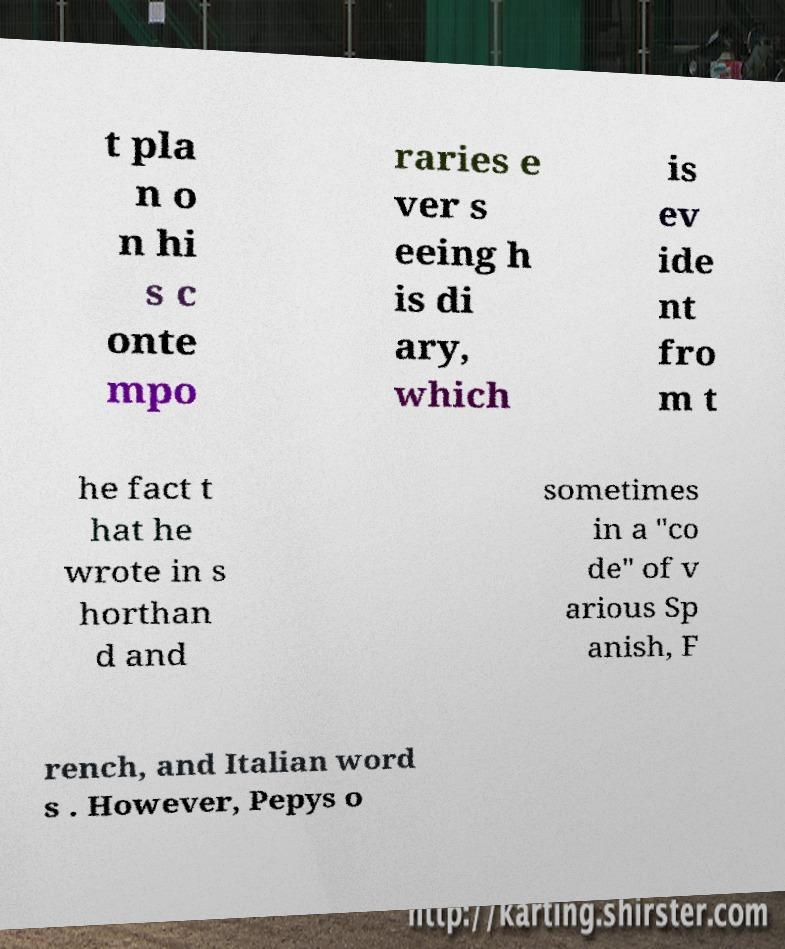Can you accurately transcribe the text from the provided image for me? t pla n o n hi s c onte mpo raries e ver s eeing h is di ary, which is ev ide nt fro m t he fact t hat he wrote in s horthan d and sometimes in a "co de" of v arious Sp anish, F rench, and Italian word s . However, Pepys o 